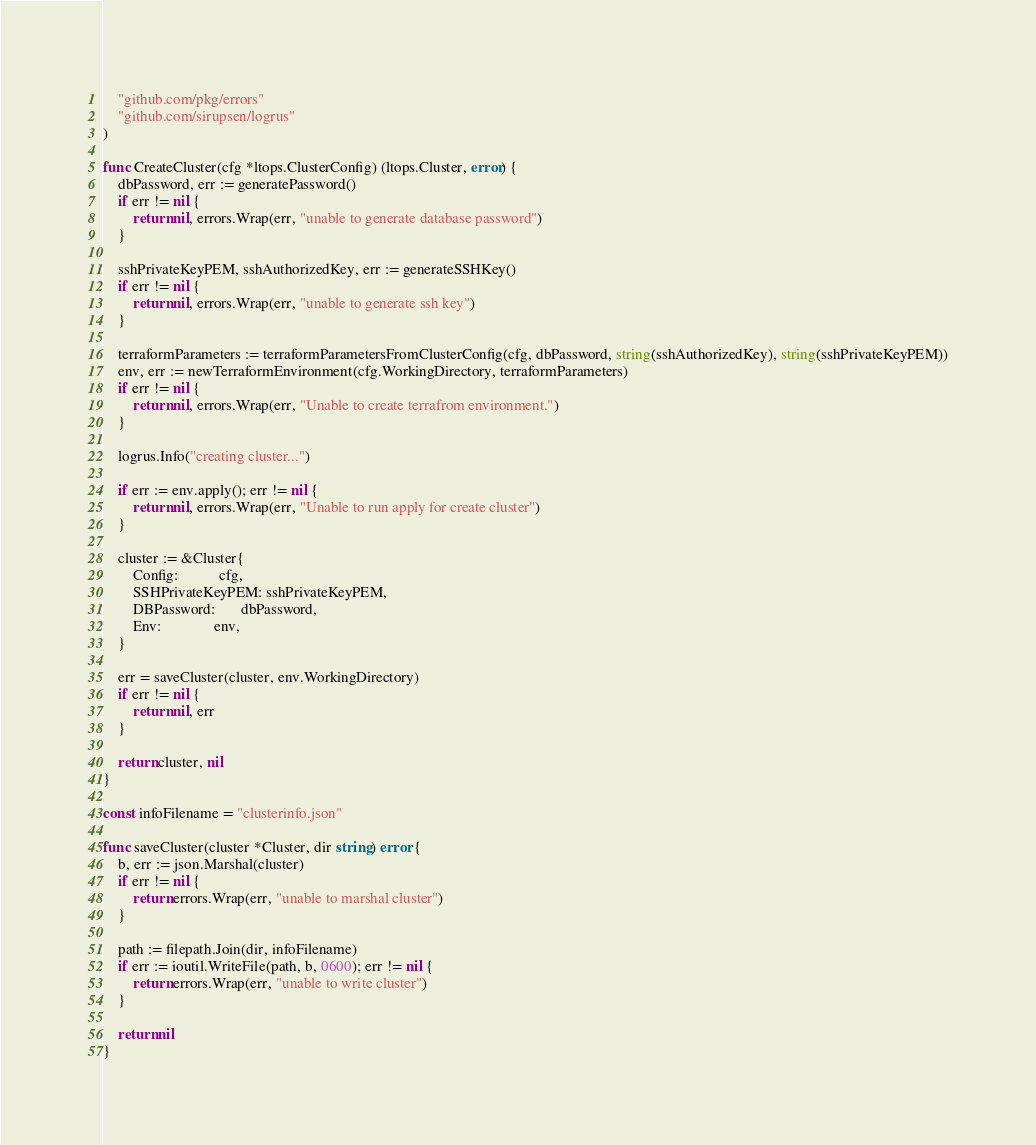<code> <loc_0><loc_0><loc_500><loc_500><_Go_>	"github.com/pkg/errors"
	"github.com/sirupsen/logrus"
)

func CreateCluster(cfg *ltops.ClusterConfig) (ltops.Cluster, error) {
	dbPassword, err := generatePassword()
	if err != nil {
		return nil, errors.Wrap(err, "unable to generate database password")
	}

	sshPrivateKeyPEM, sshAuthorizedKey, err := generateSSHKey()
	if err != nil {
		return nil, errors.Wrap(err, "unable to generate ssh key")
	}

	terraformParameters := terraformParametersFromClusterConfig(cfg, dbPassword, string(sshAuthorizedKey), string(sshPrivateKeyPEM))
	env, err := newTerraformEnvironment(cfg.WorkingDirectory, terraformParameters)
	if err != nil {
		return nil, errors.Wrap(err, "Unable to create terrafrom environment.")
	}

	logrus.Info("creating cluster...")

	if err := env.apply(); err != nil {
		return nil, errors.Wrap(err, "Unable to run apply for create cluster")
	}

	cluster := &Cluster{
		Config:           cfg,
		SSHPrivateKeyPEM: sshPrivateKeyPEM,
		DBPassword:       dbPassword,
		Env:              env,
	}

	err = saveCluster(cluster, env.WorkingDirectory)
	if err != nil {
		return nil, err
	}

	return cluster, nil
}

const infoFilename = "clusterinfo.json"

func saveCluster(cluster *Cluster, dir string) error {
	b, err := json.Marshal(cluster)
	if err != nil {
		return errors.Wrap(err, "unable to marshal cluster")
	}

	path := filepath.Join(dir, infoFilename)
	if err := ioutil.WriteFile(path, b, 0600); err != nil {
		return errors.Wrap(err, "unable to write cluster")
	}

	return nil
}
</code> 